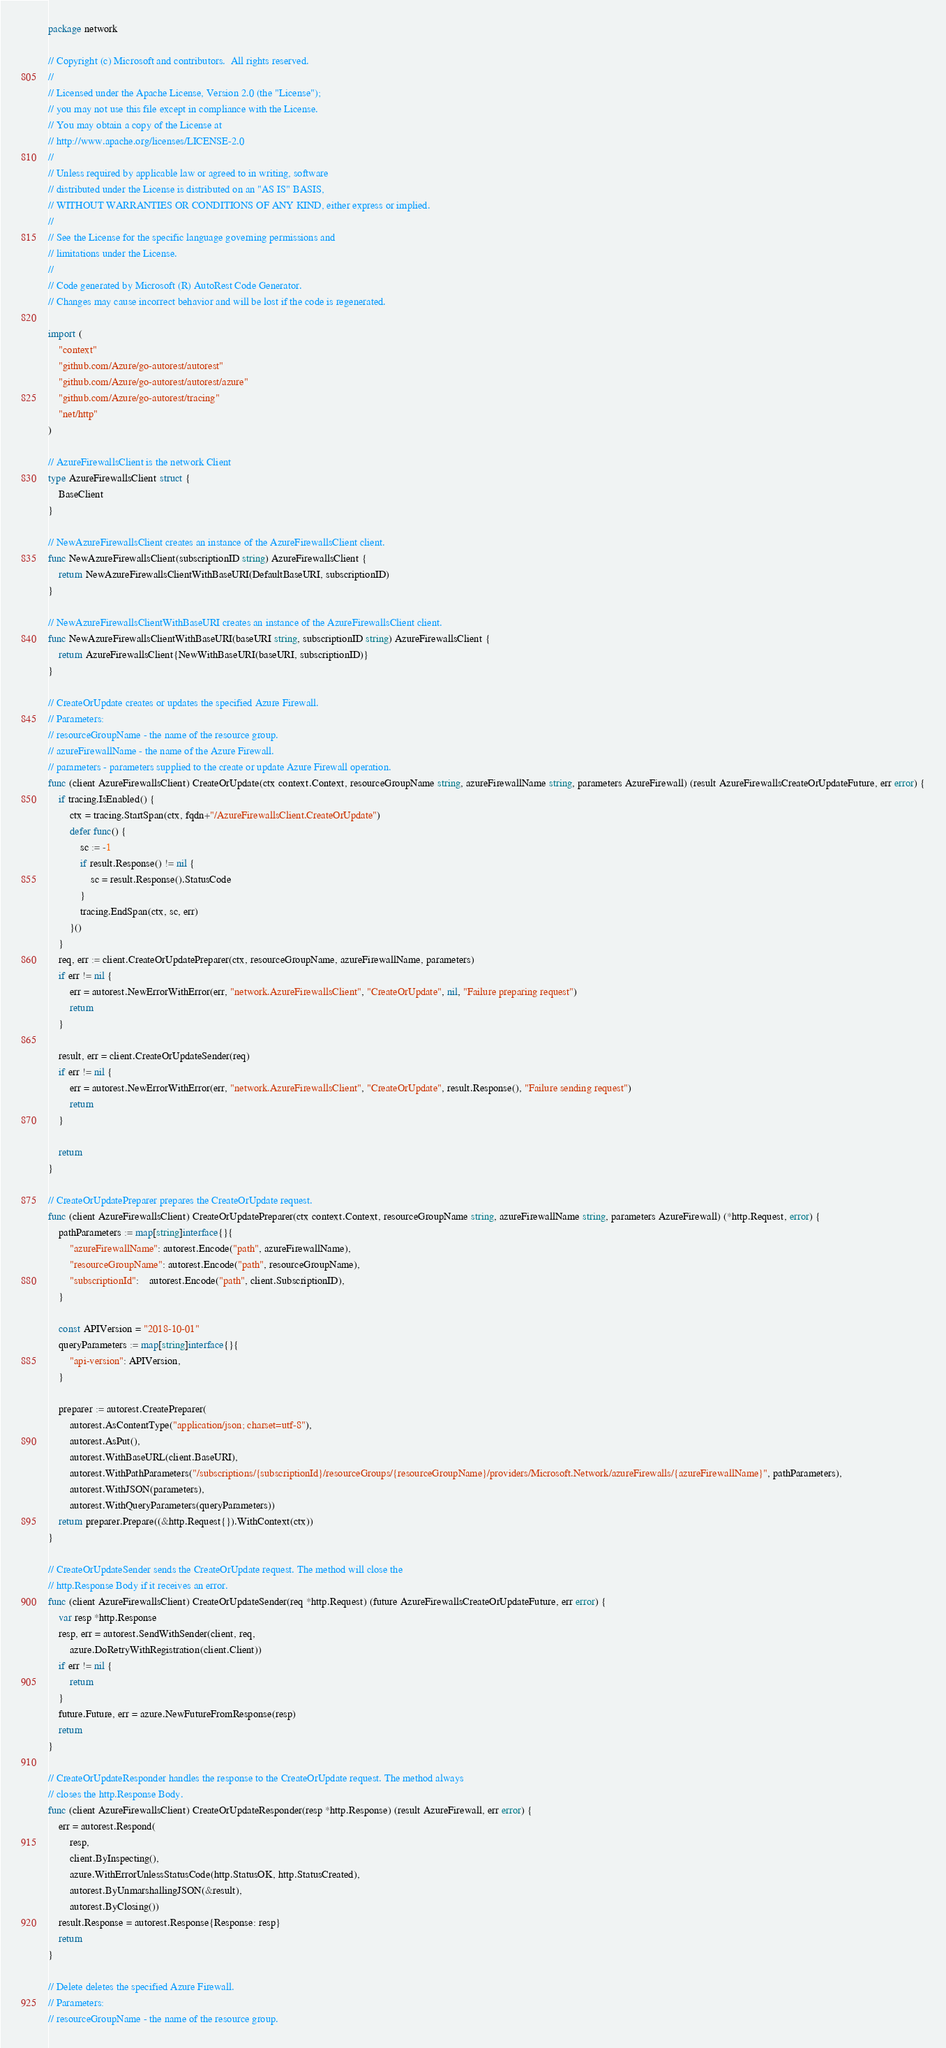Convert code to text. <code><loc_0><loc_0><loc_500><loc_500><_Go_>package network

// Copyright (c) Microsoft and contributors.  All rights reserved.
//
// Licensed under the Apache License, Version 2.0 (the "License");
// you may not use this file except in compliance with the License.
// You may obtain a copy of the License at
// http://www.apache.org/licenses/LICENSE-2.0
//
// Unless required by applicable law or agreed to in writing, software
// distributed under the License is distributed on an "AS IS" BASIS,
// WITHOUT WARRANTIES OR CONDITIONS OF ANY KIND, either express or implied.
//
// See the License for the specific language governing permissions and
// limitations under the License.
//
// Code generated by Microsoft (R) AutoRest Code Generator.
// Changes may cause incorrect behavior and will be lost if the code is regenerated.

import (
	"context"
	"github.com/Azure/go-autorest/autorest"
	"github.com/Azure/go-autorest/autorest/azure"
	"github.com/Azure/go-autorest/tracing"
	"net/http"
)

// AzureFirewallsClient is the network Client
type AzureFirewallsClient struct {
	BaseClient
}

// NewAzureFirewallsClient creates an instance of the AzureFirewallsClient client.
func NewAzureFirewallsClient(subscriptionID string) AzureFirewallsClient {
	return NewAzureFirewallsClientWithBaseURI(DefaultBaseURI, subscriptionID)
}

// NewAzureFirewallsClientWithBaseURI creates an instance of the AzureFirewallsClient client.
func NewAzureFirewallsClientWithBaseURI(baseURI string, subscriptionID string) AzureFirewallsClient {
	return AzureFirewallsClient{NewWithBaseURI(baseURI, subscriptionID)}
}

// CreateOrUpdate creates or updates the specified Azure Firewall.
// Parameters:
// resourceGroupName - the name of the resource group.
// azureFirewallName - the name of the Azure Firewall.
// parameters - parameters supplied to the create or update Azure Firewall operation.
func (client AzureFirewallsClient) CreateOrUpdate(ctx context.Context, resourceGroupName string, azureFirewallName string, parameters AzureFirewall) (result AzureFirewallsCreateOrUpdateFuture, err error) {
	if tracing.IsEnabled() {
		ctx = tracing.StartSpan(ctx, fqdn+"/AzureFirewallsClient.CreateOrUpdate")
		defer func() {
			sc := -1
			if result.Response() != nil {
				sc = result.Response().StatusCode
			}
			tracing.EndSpan(ctx, sc, err)
		}()
	}
	req, err := client.CreateOrUpdatePreparer(ctx, resourceGroupName, azureFirewallName, parameters)
	if err != nil {
		err = autorest.NewErrorWithError(err, "network.AzureFirewallsClient", "CreateOrUpdate", nil, "Failure preparing request")
		return
	}

	result, err = client.CreateOrUpdateSender(req)
	if err != nil {
		err = autorest.NewErrorWithError(err, "network.AzureFirewallsClient", "CreateOrUpdate", result.Response(), "Failure sending request")
		return
	}

	return
}

// CreateOrUpdatePreparer prepares the CreateOrUpdate request.
func (client AzureFirewallsClient) CreateOrUpdatePreparer(ctx context.Context, resourceGroupName string, azureFirewallName string, parameters AzureFirewall) (*http.Request, error) {
	pathParameters := map[string]interface{}{
		"azureFirewallName": autorest.Encode("path", azureFirewallName),
		"resourceGroupName": autorest.Encode("path", resourceGroupName),
		"subscriptionId":    autorest.Encode("path", client.SubscriptionID),
	}

	const APIVersion = "2018-10-01"
	queryParameters := map[string]interface{}{
		"api-version": APIVersion,
	}

	preparer := autorest.CreatePreparer(
		autorest.AsContentType("application/json; charset=utf-8"),
		autorest.AsPut(),
		autorest.WithBaseURL(client.BaseURI),
		autorest.WithPathParameters("/subscriptions/{subscriptionId}/resourceGroups/{resourceGroupName}/providers/Microsoft.Network/azureFirewalls/{azureFirewallName}", pathParameters),
		autorest.WithJSON(parameters),
		autorest.WithQueryParameters(queryParameters))
	return preparer.Prepare((&http.Request{}).WithContext(ctx))
}

// CreateOrUpdateSender sends the CreateOrUpdate request. The method will close the
// http.Response Body if it receives an error.
func (client AzureFirewallsClient) CreateOrUpdateSender(req *http.Request) (future AzureFirewallsCreateOrUpdateFuture, err error) {
	var resp *http.Response
	resp, err = autorest.SendWithSender(client, req,
		azure.DoRetryWithRegistration(client.Client))
	if err != nil {
		return
	}
	future.Future, err = azure.NewFutureFromResponse(resp)
	return
}

// CreateOrUpdateResponder handles the response to the CreateOrUpdate request. The method always
// closes the http.Response Body.
func (client AzureFirewallsClient) CreateOrUpdateResponder(resp *http.Response) (result AzureFirewall, err error) {
	err = autorest.Respond(
		resp,
		client.ByInspecting(),
		azure.WithErrorUnlessStatusCode(http.StatusOK, http.StatusCreated),
		autorest.ByUnmarshallingJSON(&result),
		autorest.ByClosing())
	result.Response = autorest.Response{Response: resp}
	return
}

// Delete deletes the specified Azure Firewall.
// Parameters:
// resourceGroupName - the name of the resource group.</code> 